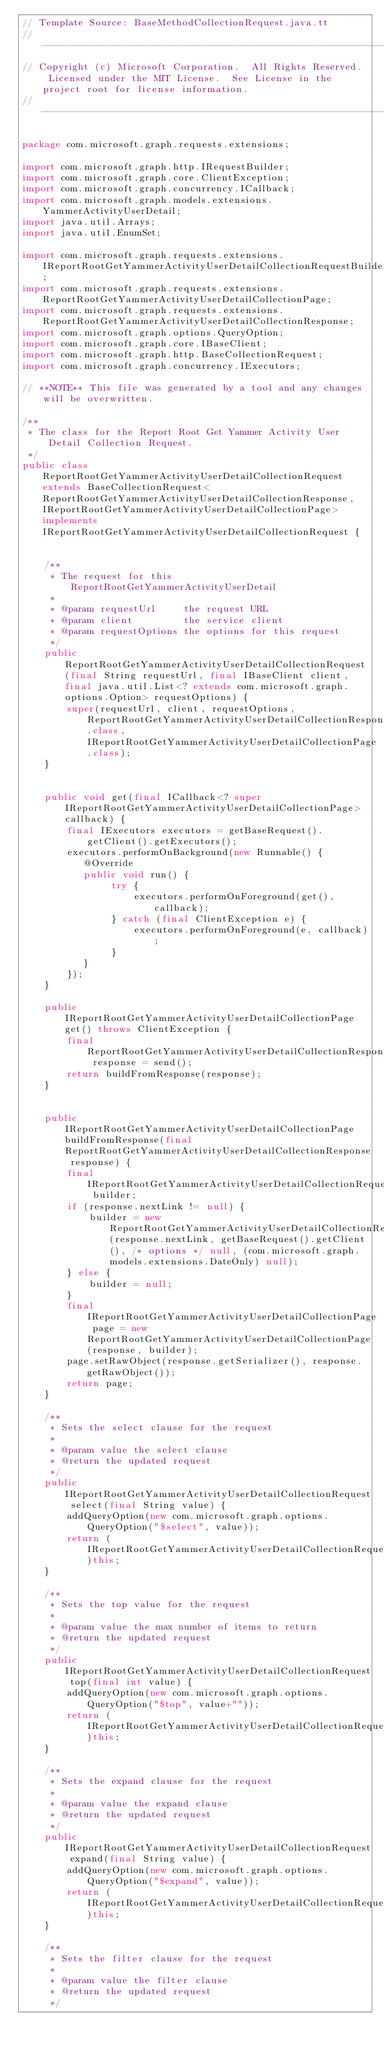Convert code to text. <code><loc_0><loc_0><loc_500><loc_500><_Java_>// Template Source: BaseMethodCollectionRequest.java.tt
// ------------------------------------------------------------------------------
// Copyright (c) Microsoft Corporation.  All Rights Reserved.  Licensed under the MIT License.  See License in the project root for license information.
// ------------------------------------------------------------------------------

package com.microsoft.graph.requests.extensions;

import com.microsoft.graph.http.IRequestBuilder;
import com.microsoft.graph.core.ClientException;
import com.microsoft.graph.concurrency.ICallback;
import com.microsoft.graph.models.extensions.YammerActivityUserDetail;
import java.util.Arrays;
import java.util.EnumSet;

import com.microsoft.graph.requests.extensions.IReportRootGetYammerActivityUserDetailCollectionRequestBuilder;
import com.microsoft.graph.requests.extensions.ReportRootGetYammerActivityUserDetailCollectionPage;
import com.microsoft.graph.requests.extensions.ReportRootGetYammerActivityUserDetailCollectionResponse;
import com.microsoft.graph.options.QueryOption;
import com.microsoft.graph.core.IBaseClient;
import com.microsoft.graph.http.BaseCollectionRequest;
import com.microsoft.graph.concurrency.IExecutors;

// **NOTE** This file was generated by a tool and any changes will be overwritten.

/**
 * The class for the Report Root Get Yammer Activity User Detail Collection Request.
 */
public class ReportRootGetYammerActivityUserDetailCollectionRequest extends BaseCollectionRequest<ReportRootGetYammerActivityUserDetailCollectionResponse, IReportRootGetYammerActivityUserDetailCollectionPage> implements IReportRootGetYammerActivityUserDetailCollectionRequest {


    /**
     * The request for this ReportRootGetYammerActivityUserDetail
     *
     * @param requestUrl     the request URL
     * @param client         the service client
     * @param requestOptions the options for this request
     */
    public ReportRootGetYammerActivityUserDetailCollectionRequest(final String requestUrl, final IBaseClient client, final java.util.List<? extends com.microsoft.graph.options.Option> requestOptions) {
        super(requestUrl, client, requestOptions, ReportRootGetYammerActivityUserDetailCollectionResponse.class, IReportRootGetYammerActivityUserDetailCollectionPage.class);
    }


    public void get(final ICallback<? super IReportRootGetYammerActivityUserDetailCollectionPage> callback) {
        final IExecutors executors = getBaseRequest().getClient().getExecutors();
        executors.performOnBackground(new Runnable() {
           @Override
           public void run() {
                try {
                    executors.performOnForeground(get(), callback);
                } catch (final ClientException e) {
                    executors.performOnForeground(e, callback);
                }
           }
        });
    }

    public IReportRootGetYammerActivityUserDetailCollectionPage get() throws ClientException {
        final ReportRootGetYammerActivityUserDetailCollectionResponse response = send();
        return buildFromResponse(response);
    }


    public IReportRootGetYammerActivityUserDetailCollectionPage buildFromResponse(final ReportRootGetYammerActivityUserDetailCollectionResponse response) {
        final IReportRootGetYammerActivityUserDetailCollectionRequestBuilder builder;
        if (response.nextLink != null) {
            builder = new ReportRootGetYammerActivityUserDetailCollectionRequestBuilder(response.nextLink, getBaseRequest().getClient(), /* options */ null, (com.microsoft.graph.models.extensions.DateOnly) null);
        } else {
            builder = null;
        }
        final IReportRootGetYammerActivityUserDetailCollectionPage page = new ReportRootGetYammerActivityUserDetailCollectionPage(response, builder);
        page.setRawObject(response.getSerializer(), response.getRawObject());
        return page;
    }

    /**
     * Sets the select clause for the request
     *
     * @param value the select clause
     * @return the updated request
     */
    public IReportRootGetYammerActivityUserDetailCollectionRequest select(final String value) {
        addQueryOption(new com.microsoft.graph.options.QueryOption("$select", value));
        return (IReportRootGetYammerActivityUserDetailCollectionRequest)this;
    }

    /**
     * Sets the top value for the request
     *
     * @param value the max number of items to return
     * @return the updated request
     */
    public IReportRootGetYammerActivityUserDetailCollectionRequest top(final int value) {
        addQueryOption(new com.microsoft.graph.options.QueryOption("$top", value+""));
        return (IReportRootGetYammerActivityUserDetailCollectionRequest)this;
    }

    /**
     * Sets the expand clause for the request
     *
     * @param value the expand clause
     * @return the updated request
     */
    public IReportRootGetYammerActivityUserDetailCollectionRequest expand(final String value) {
        addQueryOption(new com.microsoft.graph.options.QueryOption("$expand", value));
        return (IReportRootGetYammerActivityUserDetailCollectionRequest)this;
    }

    /**
     * Sets the filter clause for the request
     *
     * @param value the filter clause
     * @return the updated request
     */</code> 